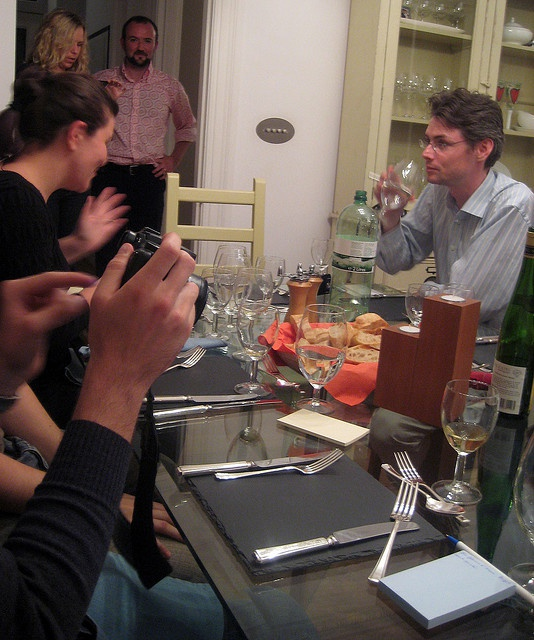Describe the objects in this image and their specific colors. I can see dining table in darkgray, gray, black, and maroon tones, people in darkgray, black, maroon, brown, and blue tones, people in darkgray, gray, brown, and black tones, people in darkgray, black, maroon, and brown tones, and people in darkgray, black, brown, and maroon tones in this image. 